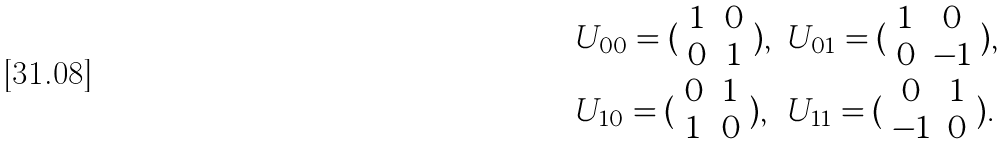<formula> <loc_0><loc_0><loc_500><loc_500>\begin{array} { l l } U _ { 0 0 } = ( \begin{array} { c c } 1 & 0 \\ 0 & 1 \end{array} ) , & U _ { 0 1 } = ( \begin{array} { c c } 1 & 0 \\ 0 & - 1 \end{array} ) , \\ U _ { 1 0 } = ( \begin{array} { c c } 0 & 1 \\ 1 & 0 \end{array} ) , & U _ { 1 1 } = ( \begin{array} { c c } 0 & 1 \\ - 1 & 0 \end{array} ) . \end{array}</formula> 